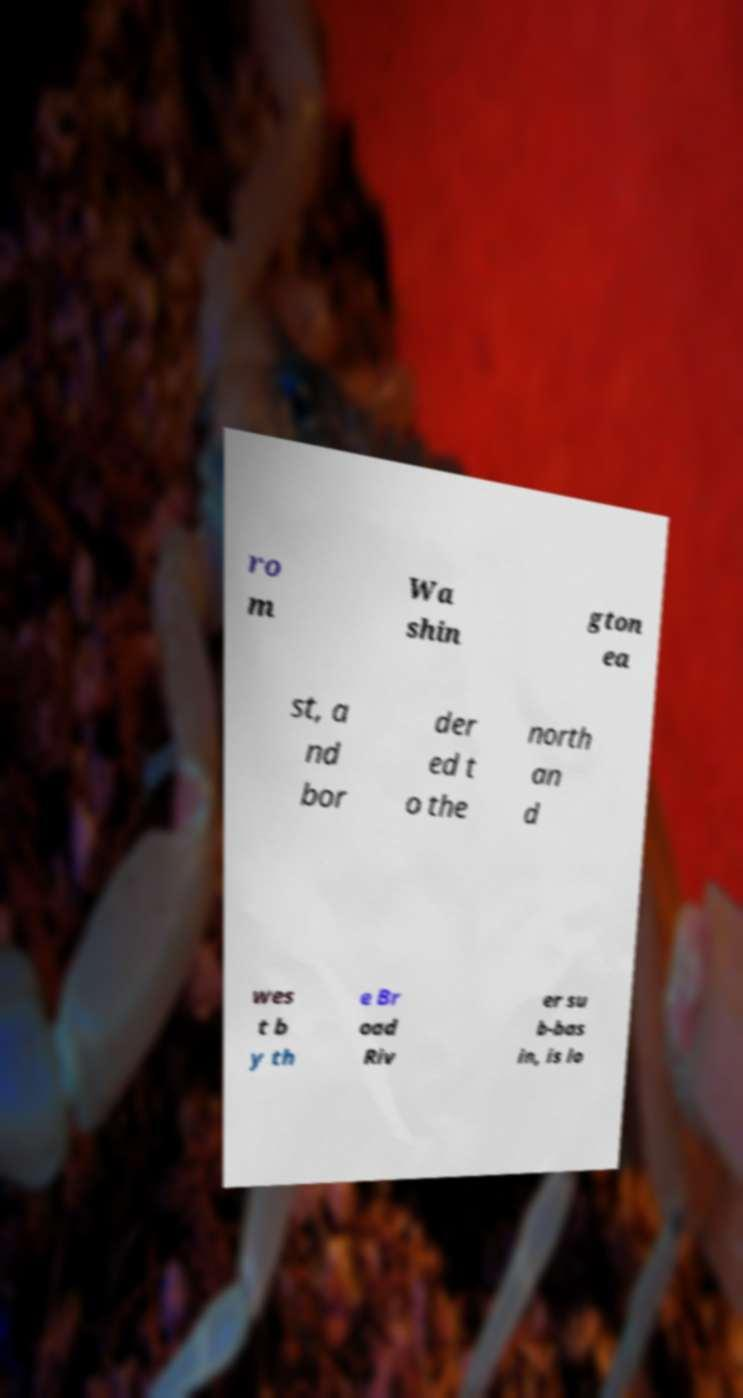There's text embedded in this image that I need extracted. Can you transcribe it verbatim? ro m Wa shin gton ea st, a nd bor der ed t o the north an d wes t b y th e Br oad Riv er su b-bas in, is lo 